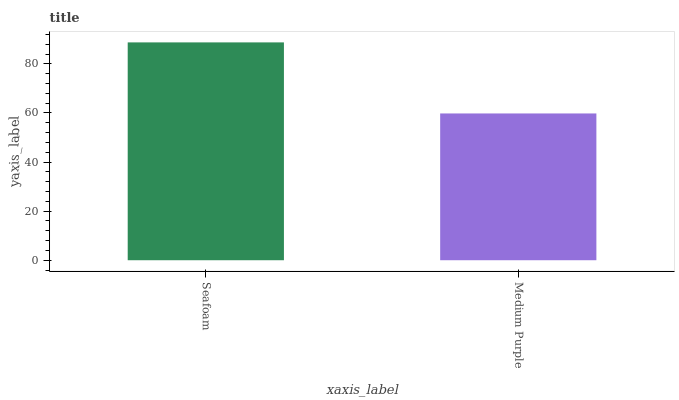Is Medium Purple the minimum?
Answer yes or no. Yes. Is Seafoam the maximum?
Answer yes or no. Yes. Is Medium Purple the maximum?
Answer yes or no. No. Is Seafoam greater than Medium Purple?
Answer yes or no. Yes. Is Medium Purple less than Seafoam?
Answer yes or no. Yes. Is Medium Purple greater than Seafoam?
Answer yes or no. No. Is Seafoam less than Medium Purple?
Answer yes or no. No. Is Seafoam the high median?
Answer yes or no. Yes. Is Medium Purple the low median?
Answer yes or no. Yes. Is Medium Purple the high median?
Answer yes or no. No. Is Seafoam the low median?
Answer yes or no. No. 